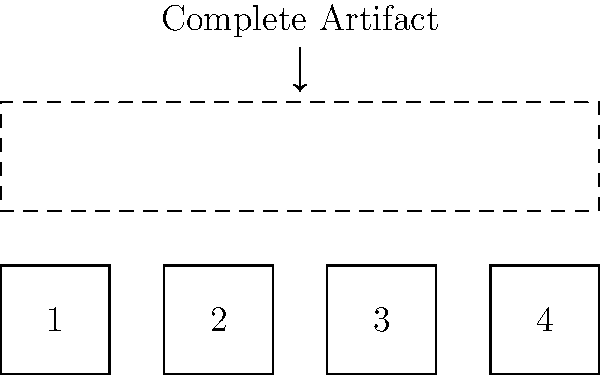Arrange the numbered tool fragments to form the complete artifact shown in the dashed outline. What is the correct order of the fragments from left to right? To solve this spatial intelligence problem, we need to follow these steps:

1. Observe the shape and size of each numbered fragment.
2. Compare the fragments to the dashed outline of the complete artifact.
3. Mentally rotate and arrange the fragments to fit within the outline.
4. Determine the correct order of fragments from left to right.

Analysis:
- Fragment 1 has a straight edge on the left, which matches the left side of the complete artifact.
- Fragment 4 has a straight edge on the right, which matches the right side of the complete artifact.
- Fragments 2 and 3 are similar in shape and size, fitting between 1 and 4.
- The complete artifact is rectangular, suggesting that all fragments should align without gaps.

Conclusion:
The correct arrangement from left to right is 1, 2, 3, 4. This order creates a continuous, rectangular shape that matches the dashed outline of the complete artifact.
Answer: 1, 2, 3, 4 